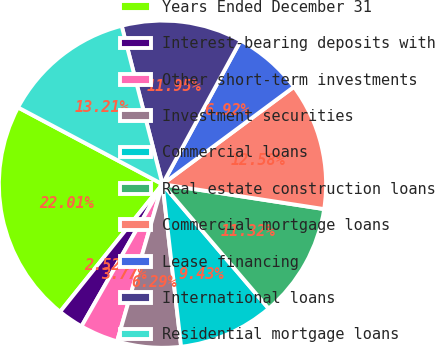Convert chart to OTSL. <chart><loc_0><loc_0><loc_500><loc_500><pie_chart><fcel>Years Ended December 31<fcel>Interest-bearing deposits with<fcel>Other short-term investments<fcel>Investment securities<fcel>Commercial loans<fcel>Real estate construction loans<fcel>Commercial mortgage loans<fcel>Lease financing<fcel>International loans<fcel>Residential mortgage loans<nl><fcel>22.01%<fcel>2.52%<fcel>3.77%<fcel>6.29%<fcel>9.43%<fcel>11.32%<fcel>12.58%<fcel>6.92%<fcel>11.95%<fcel>13.21%<nl></chart> 